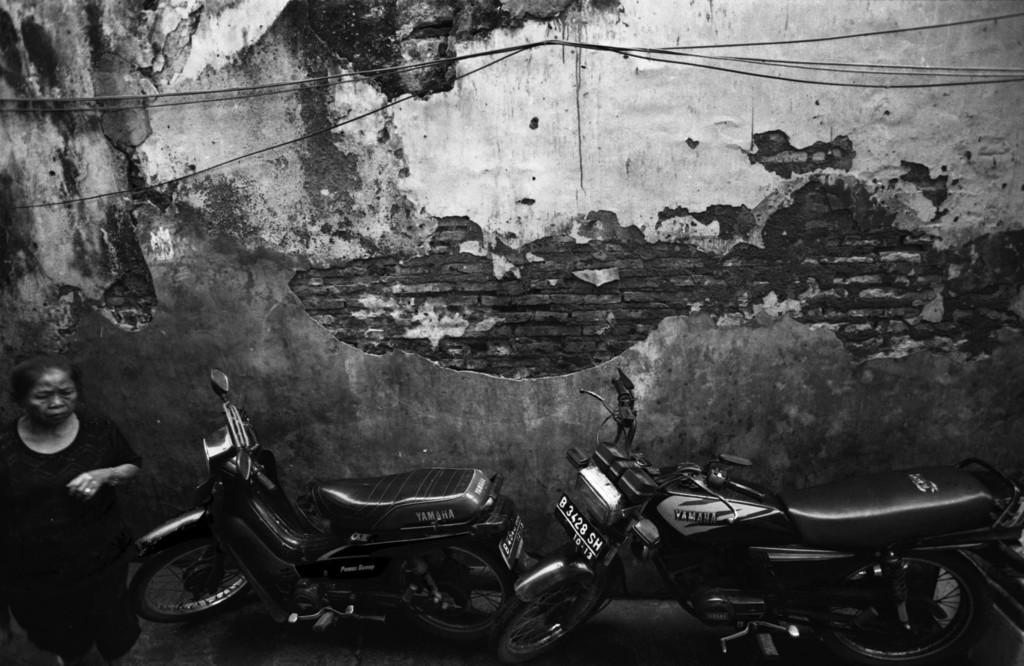What can be seen in the image? There are vehicles and women standing in front of a wall in the image. Can you describe the vehicles in the image? The provided facts do not give specific details about the vehicles, so we cannot describe them further. What is the women's position in relation to the wall? The women are standing in front of the wall. What type of crime is being committed in the image? There is no indication of a crime being committed in the image. What pest can be seen crawling on the wall in the image? There is no pest visible on the wall in the image. 